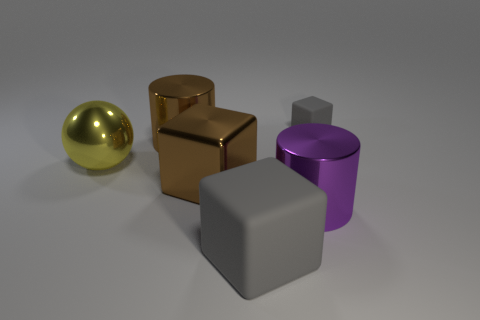Add 3 large matte blocks. How many objects exist? 9 Subtract all cylinders. How many objects are left? 4 Add 4 blocks. How many blocks are left? 7 Add 4 tiny cubes. How many tiny cubes exist? 5 Subtract 0 blue blocks. How many objects are left? 6 Subtract all big green matte spheres. Subtract all rubber cubes. How many objects are left? 4 